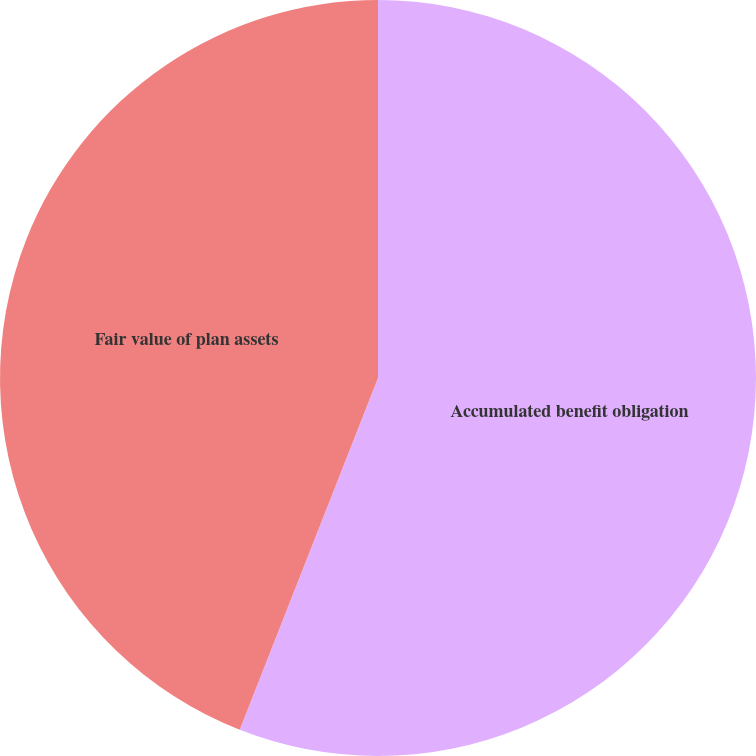Convert chart. <chart><loc_0><loc_0><loc_500><loc_500><pie_chart><fcel>Accumulated benefit obligation<fcel>Fair value of plan assets<nl><fcel>55.96%<fcel>44.04%<nl></chart> 